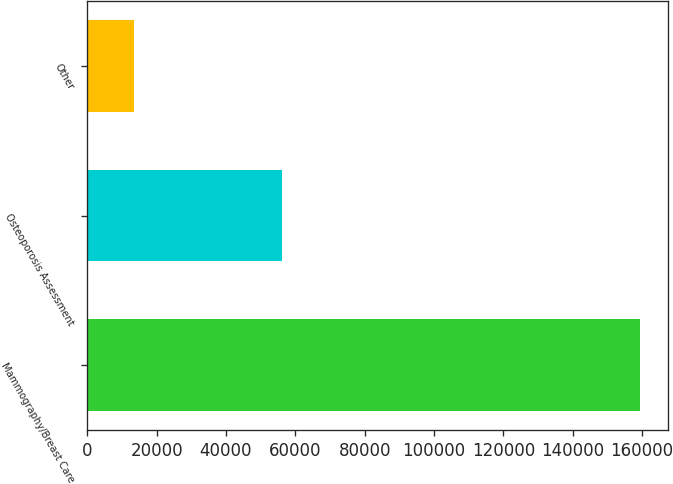<chart> <loc_0><loc_0><loc_500><loc_500><bar_chart><fcel>Mammography/Breast Care<fcel>Osteoporosis Assessment<fcel>Other<nl><fcel>159469<fcel>56065<fcel>13541<nl></chart> 